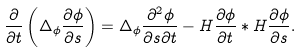<formula> <loc_0><loc_0><loc_500><loc_500>\frac { \partial } { \partial t } \left ( \Delta _ { \phi } \frac { \partial \phi } { \partial s } \right ) = \Delta _ { \phi } \frac { \partial ^ { 2 } \phi } { \partial s \partial t } - H \frac { \partial \phi } { \partial t } * H \frac { \partial \phi } { \partial s } .</formula> 